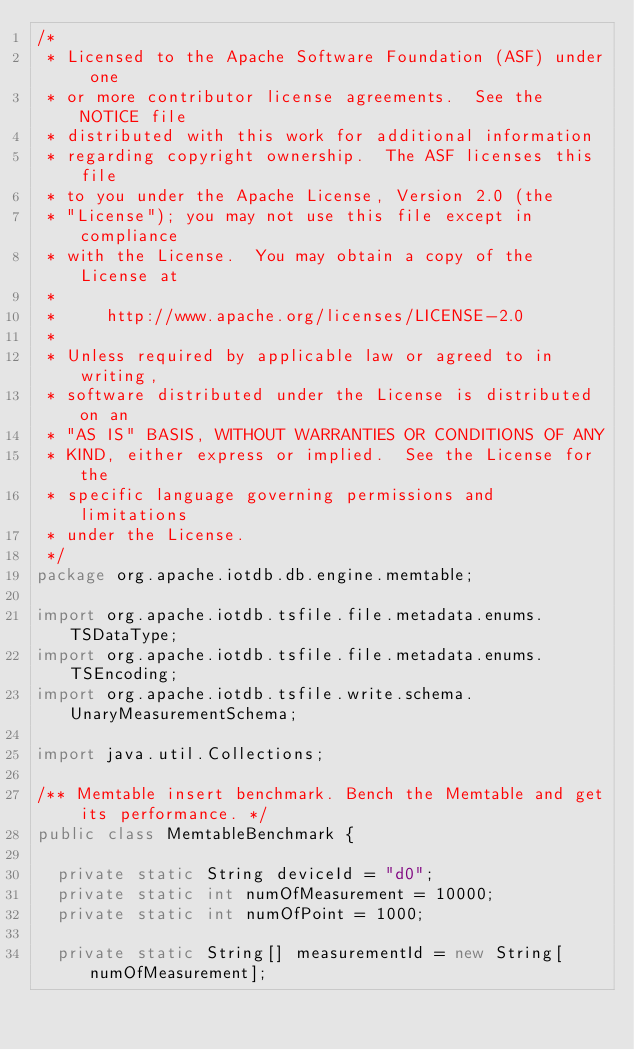<code> <loc_0><loc_0><loc_500><loc_500><_Java_>/*
 * Licensed to the Apache Software Foundation (ASF) under one
 * or more contributor license agreements.  See the NOTICE file
 * distributed with this work for additional information
 * regarding copyright ownership.  The ASF licenses this file
 * to you under the Apache License, Version 2.0 (the
 * "License"); you may not use this file except in compliance
 * with the License.  You may obtain a copy of the License at
 *
 *     http://www.apache.org/licenses/LICENSE-2.0
 *
 * Unless required by applicable law or agreed to in writing,
 * software distributed under the License is distributed on an
 * "AS IS" BASIS, WITHOUT WARRANTIES OR CONDITIONS OF ANY
 * KIND, either express or implied.  See the License for the
 * specific language governing permissions and limitations
 * under the License.
 */
package org.apache.iotdb.db.engine.memtable;

import org.apache.iotdb.tsfile.file.metadata.enums.TSDataType;
import org.apache.iotdb.tsfile.file.metadata.enums.TSEncoding;
import org.apache.iotdb.tsfile.write.schema.UnaryMeasurementSchema;

import java.util.Collections;

/** Memtable insert benchmark. Bench the Memtable and get its performance. */
public class MemtableBenchmark {

  private static String deviceId = "d0";
  private static int numOfMeasurement = 10000;
  private static int numOfPoint = 1000;

  private static String[] measurementId = new String[numOfMeasurement];</code> 